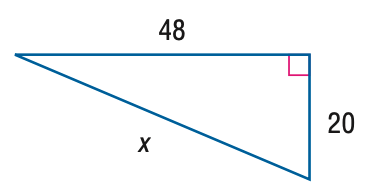Question: Find x.
Choices:
A. 50
B. 52
C. 54
D. 56
Answer with the letter. Answer: B 